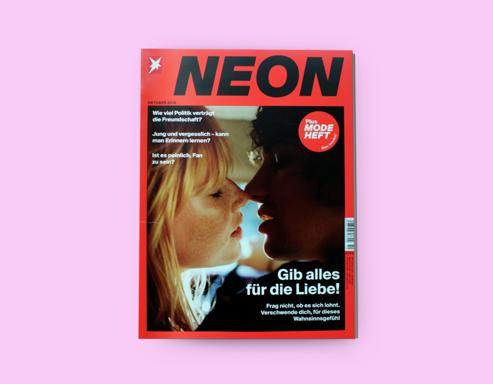Do the small texts on the cover reveal anything interesting about this edition of the magazine? The smaller texts on the cover serve as teasers to the articles within. They give us a glimpse into the variety of topics covered in this edition, potentially ranging from political issues to youth culture. These snippets are strategically placed to engage readers' curiosities and encourage them to delve into the magazine for a deeper exploration of the featured stories. 